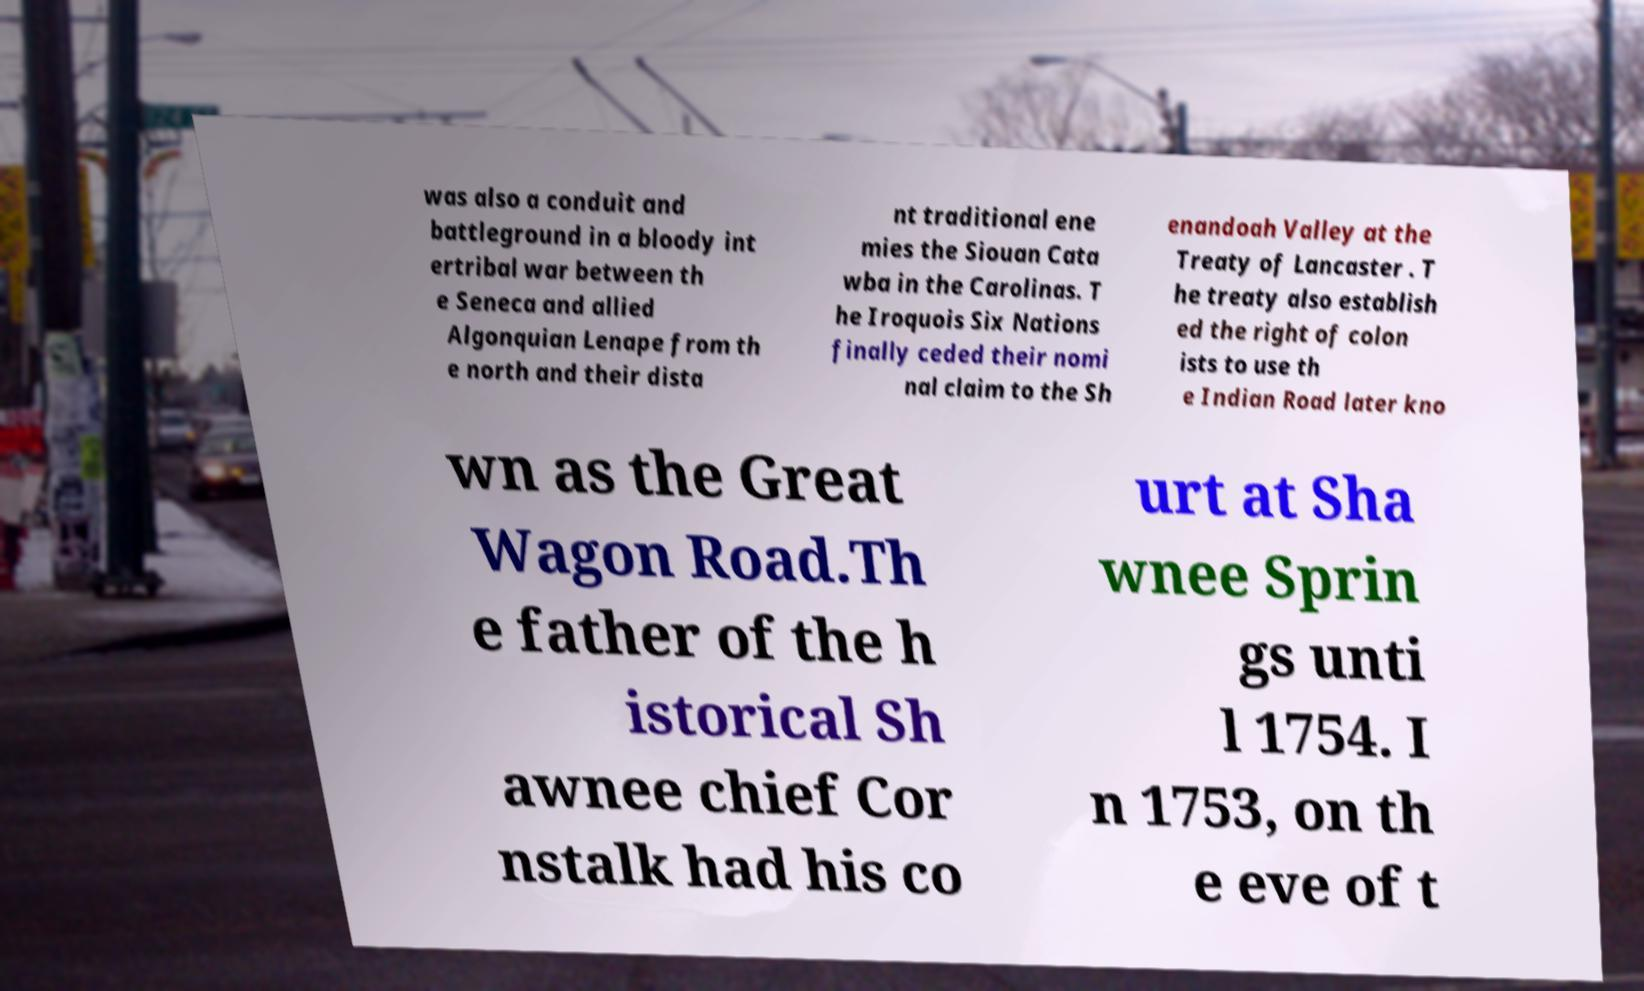There's text embedded in this image that I need extracted. Can you transcribe it verbatim? was also a conduit and battleground in a bloody int ertribal war between th e Seneca and allied Algonquian Lenape from th e north and their dista nt traditional ene mies the Siouan Cata wba in the Carolinas. T he Iroquois Six Nations finally ceded their nomi nal claim to the Sh enandoah Valley at the Treaty of Lancaster . T he treaty also establish ed the right of colon ists to use th e Indian Road later kno wn as the Great Wagon Road.Th e father of the h istorical Sh awnee chief Cor nstalk had his co urt at Sha wnee Sprin gs unti l 1754. I n 1753, on th e eve of t 